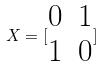<formula> <loc_0><loc_0><loc_500><loc_500>X = [ \begin{matrix} 0 & 1 \\ 1 & 0 \end{matrix} ]</formula> 